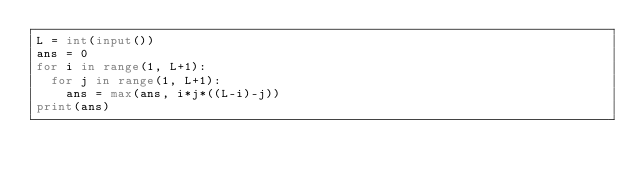Convert code to text. <code><loc_0><loc_0><loc_500><loc_500><_Python_>L = int(input())
ans = 0
for i in range(1, L+1):
  for j in range(1, L+1):
    ans = max(ans, i*j*((L-i)-j))
print(ans)</code> 